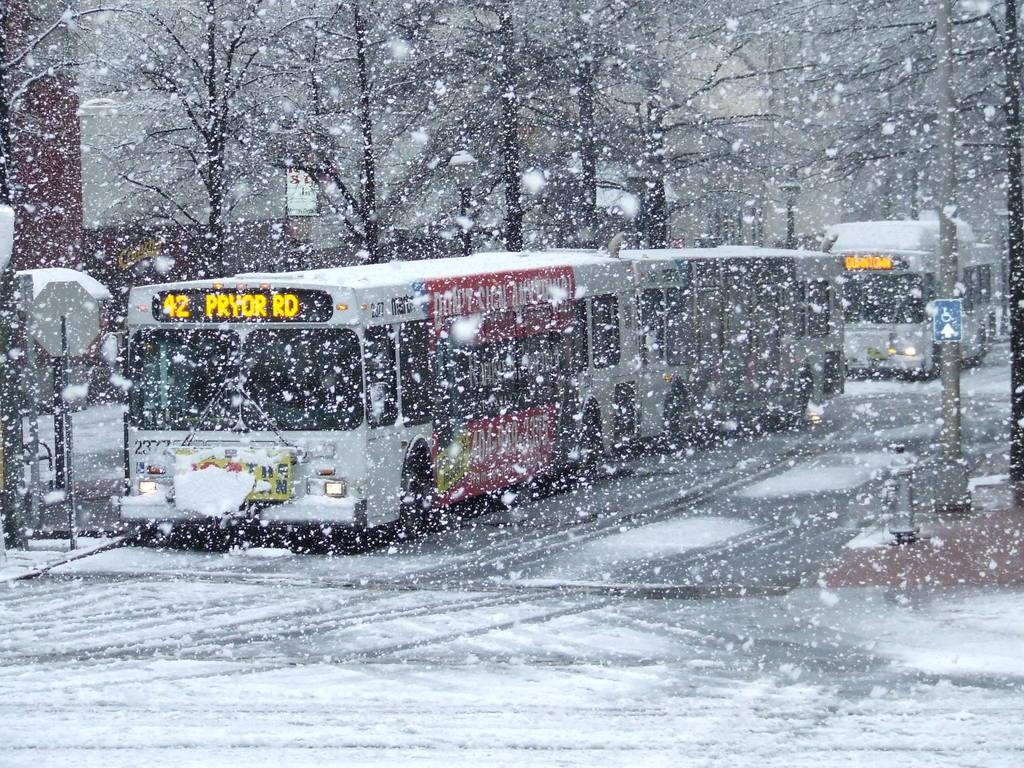What type of vehicles can be seen in the image? There are buses in the image. What structures are present in the image? There are light poles, buildings, and sign boards in the image. What is the weather condition in the image? Snow is visible in the image. What type of vegetation is present in the image? There are trees in the image. What type of advice can be seen written on the sign boards in the image? There is no advice visible on the sign boards in the image; they contain information or directions. What type of material is the brain made of in the image? There is no brain present in the image. 